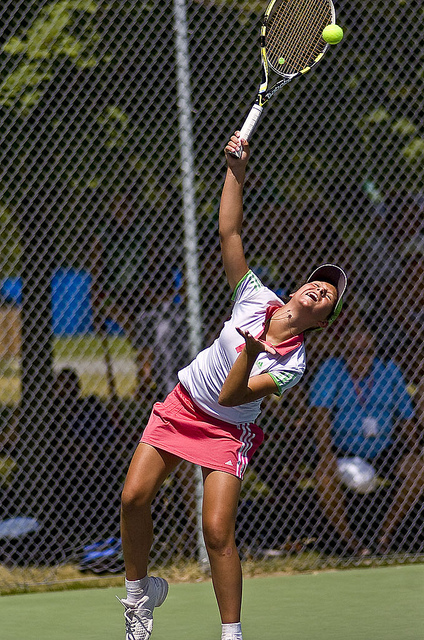What team does the woman play for? The player is dressed in a red and white kit, colors that are fairly common and not specific to any known team. Without more context or visible team logos, it's not possible to determine exactly which team she plays for, if any. 